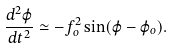Convert formula to latex. <formula><loc_0><loc_0><loc_500><loc_500>\frac { d ^ { 2 } \varphi } { d t ^ { 2 } } \simeq - f ^ { 2 } _ { o } \sin ( \varphi - \varphi _ { o } ) .</formula> 